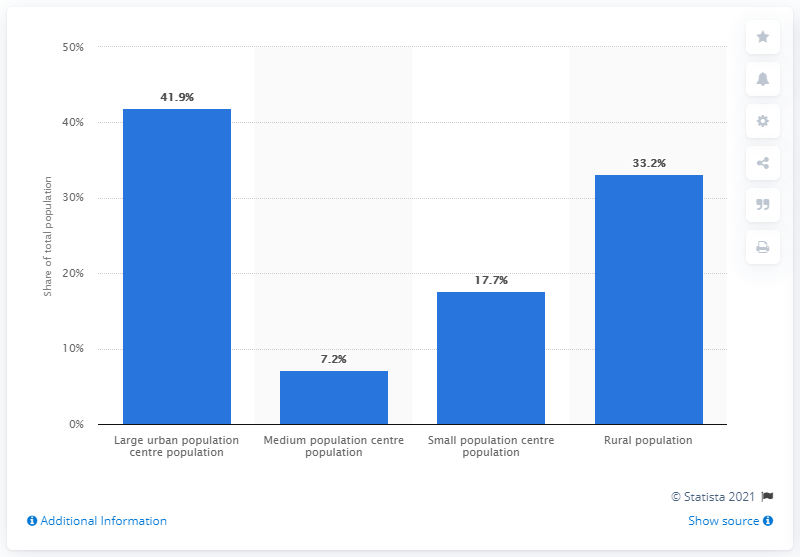Indicate a few pertinent items in this graphic. The difference between the highest and lowest blue bar is 34.7. In 2016, the distribution of Saskatchewan's population was highest in rural areas, with 41.9% of the population living in this type of area. 